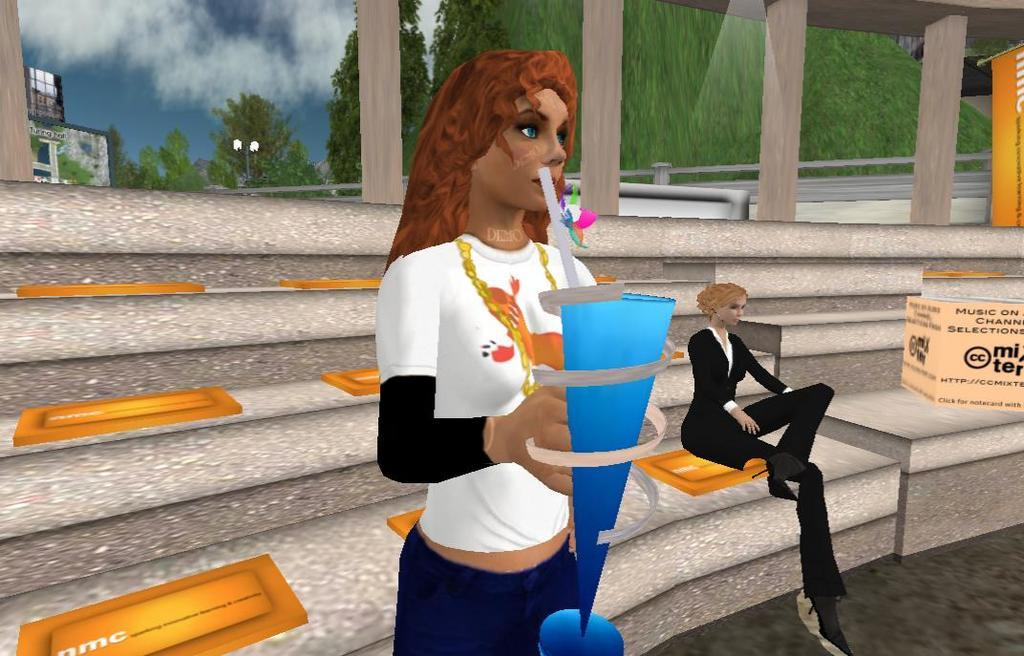What type of image is being described? The image is an animated image. What is the woman holding in the image? The woman is standing and holding an object in the image. Where is the other woman located in the image? The other woman is sitting on staircases in the image. What type of food is the woman holding in the image? The woman is not holding any food in the image; she is holding an unspecified object. How many parcels can be seen in the image? There are no parcels present in the image. 